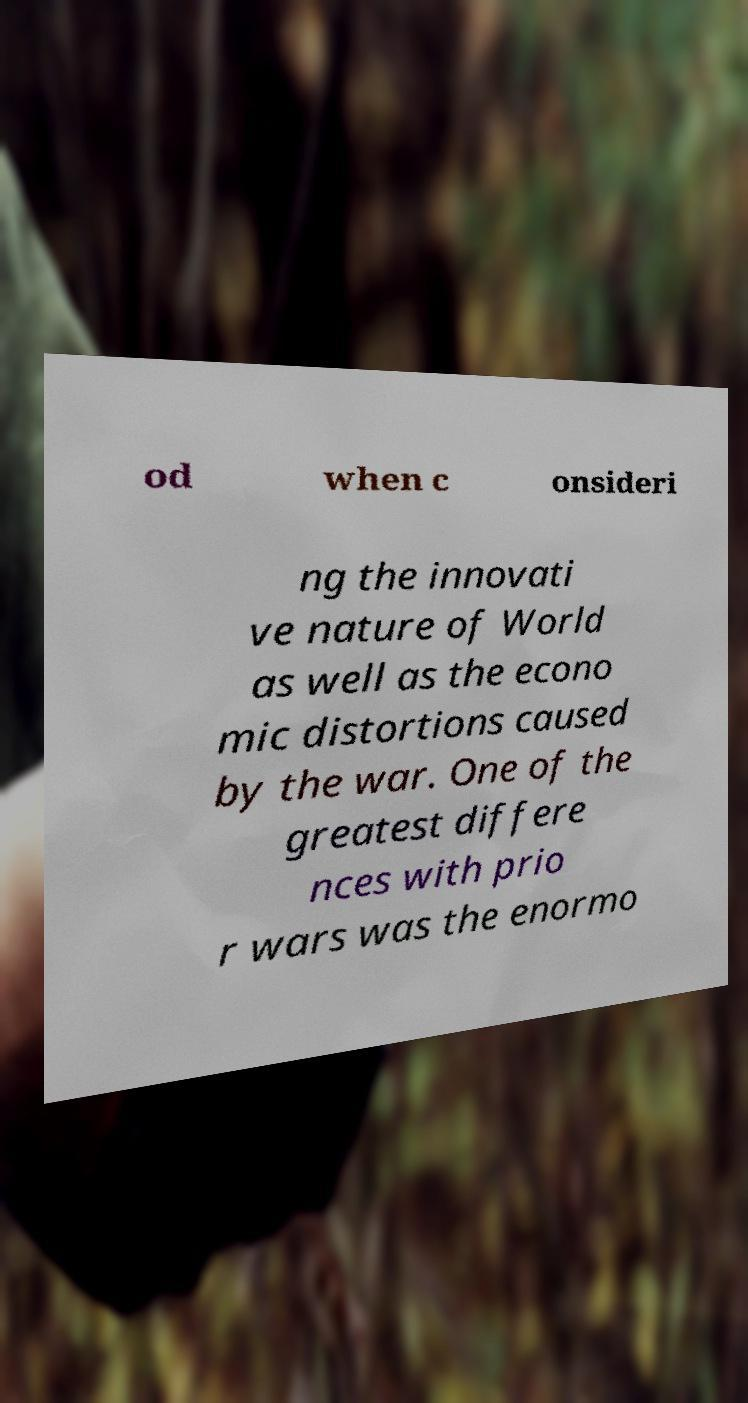Could you assist in decoding the text presented in this image and type it out clearly? od when c onsideri ng the innovati ve nature of World as well as the econo mic distortions caused by the war. One of the greatest differe nces with prio r wars was the enormo 